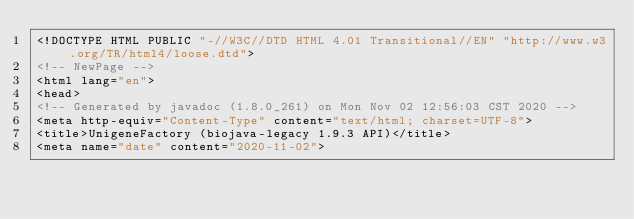<code> <loc_0><loc_0><loc_500><loc_500><_HTML_><!DOCTYPE HTML PUBLIC "-//W3C//DTD HTML 4.01 Transitional//EN" "http://www.w3.org/TR/html4/loose.dtd">
<!-- NewPage -->
<html lang="en">
<head>
<!-- Generated by javadoc (1.8.0_261) on Mon Nov 02 12:56:03 CST 2020 -->
<meta http-equiv="Content-Type" content="text/html; charset=UTF-8">
<title>UnigeneFactory (biojava-legacy 1.9.3 API)</title>
<meta name="date" content="2020-11-02"></code> 